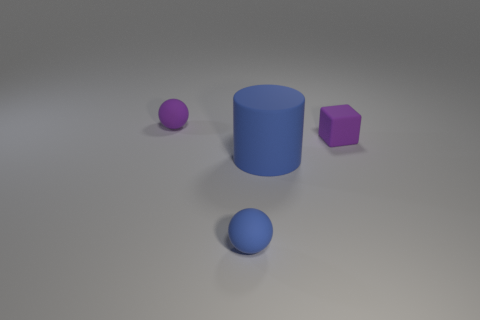Subtract all red cubes. Subtract all gray cylinders. How many cubes are left? 1 Add 4 purple rubber objects. How many objects exist? 8 Subtract all cylinders. How many objects are left? 3 Subtract 1 purple cubes. How many objects are left? 3 Subtract all small spheres. Subtract all purple rubber balls. How many objects are left? 1 Add 4 small purple things. How many small purple things are left? 6 Add 1 blue cylinders. How many blue cylinders exist? 2 